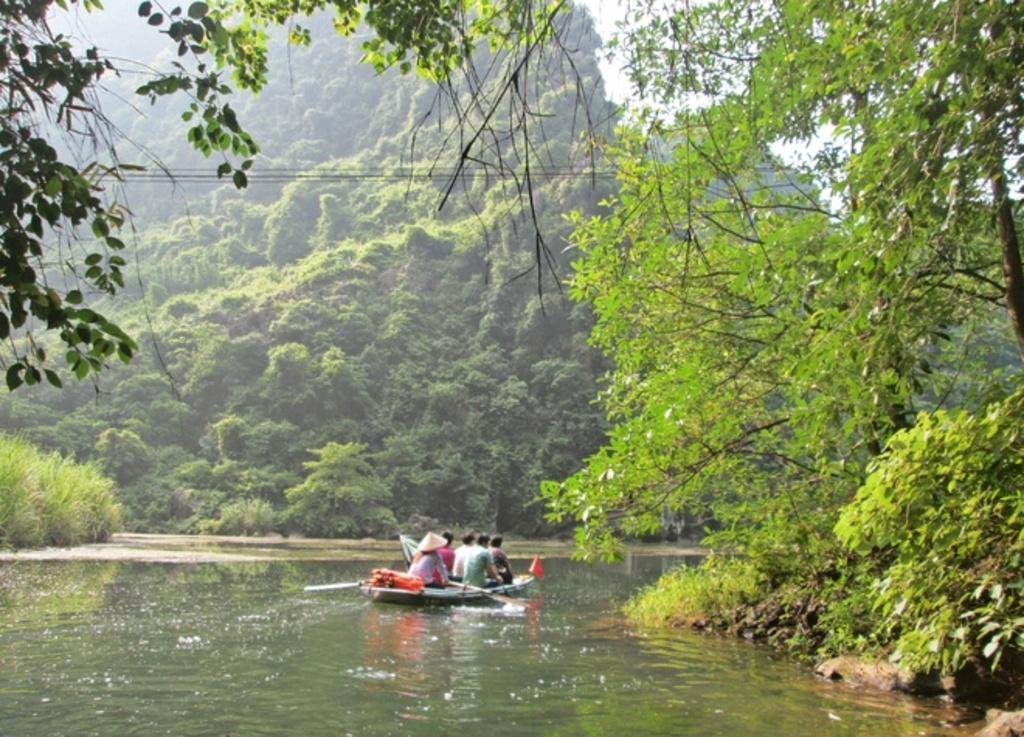Can you describe this image briefly? In this picture we can see a few people sitting on a boat in water. There are few trees on the right side. We can see a plant on the left side. Some greenery is visible in the background. 